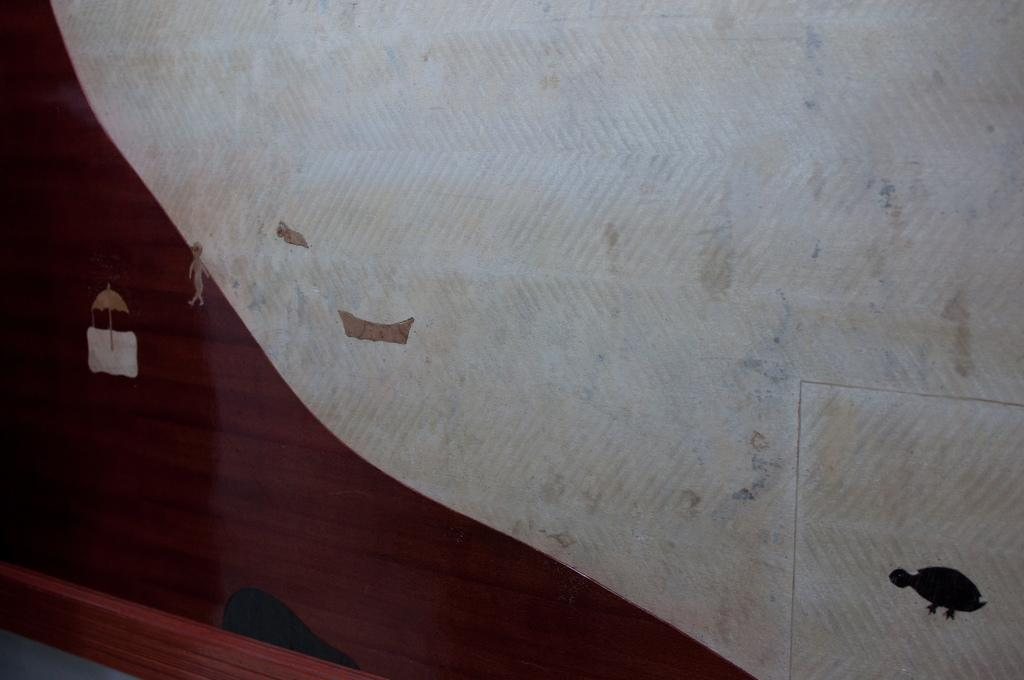What is depicted on the wall in the image? There is art on the wall in the image. What specific elements can be seen in the art? The art includes a tortoise, a man, a boat, and an umbrella. Are there any other elements in the art besides the ones mentioned? Yes, there are other unspecified elements in the art. What type of zinc is used to create the boat in the art? There is no mention of zinc being used in the creation of the art, and the boat is a part of the artwork, not a separate material. 